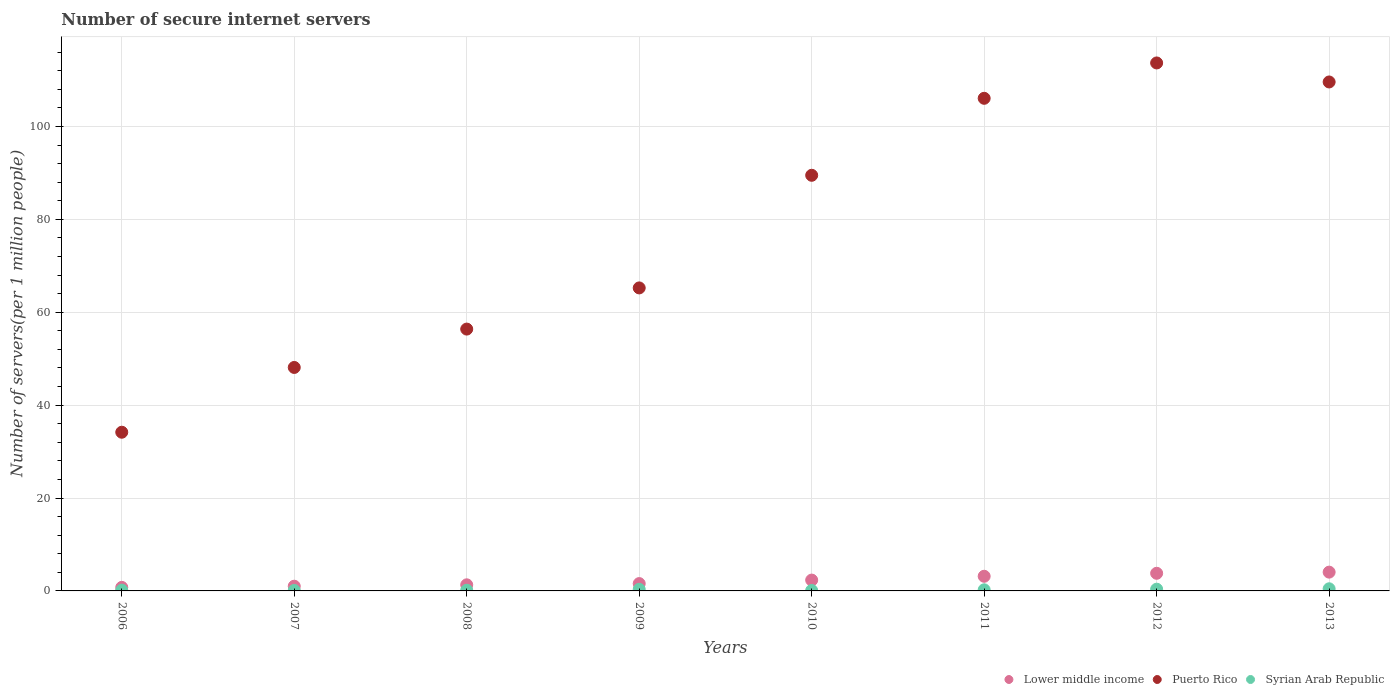Is the number of dotlines equal to the number of legend labels?
Give a very brief answer. Yes. What is the number of secure internet servers in Puerto Rico in 2006?
Make the answer very short. 34.16. Across all years, what is the maximum number of secure internet servers in Lower middle income?
Your response must be concise. 4.04. Across all years, what is the minimum number of secure internet servers in Puerto Rico?
Provide a succinct answer. 34.16. In which year was the number of secure internet servers in Puerto Rico minimum?
Provide a short and direct response. 2006. What is the total number of secure internet servers in Puerto Rico in the graph?
Offer a terse response. 622.65. What is the difference between the number of secure internet servers in Syrian Arab Republic in 2006 and that in 2010?
Make the answer very short. 0.06. What is the difference between the number of secure internet servers in Lower middle income in 2009 and the number of secure internet servers in Syrian Arab Republic in 2007?
Offer a very short reply. 1.48. What is the average number of secure internet servers in Lower middle income per year?
Give a very brief answer. 2.25. In the year 2006, what is the difference between the number of secure internet servers in Puerto Rico and number of secure internet servers in Lower middle income?
Ensure brevity in your answer.  33.4. What is the ratio of the number of secure internet servers in Lower middle income in 2006 to that in 2007?
Ensure brevity in your answer.  0.75. What is the difference between the highest and the second highest number of secure internet servers in Puerto Rico?
Your answer should be compact. 4.09. What is the difference between the highest and the lowest number of secure internet servers in Syrian Arab Republic?
Your answer should be compact. 0.36. In how many years, is the number of secure internet servers in Puerto Rico greater than the average number of secure internet servers in Puerto Rico taken over all years?
Offer a very short reply. 4. Is the sum of the number of secure internet servers in Syrian Arab Republic in 2007 and 2012 greater than the maximum number of secure internet servers in Puerto Rico across all years?
Ensure brevity in your answer.  No. Does the number of secure internet servers in Lower middle income monotonically increase over the years?
Provide a short and direct response. Yes. How many dotlines are there?
Your answer should be very brief. 3. How many years are there in the graph?
Ensure brevity in your answer.  8. What is the difference between two consecutive major ticks on the Y-axis?
Make the answer very short. 20. Does the graph contain any zero values?
Your answer should be very brief. No. Where does the legend appear in the graph?
Your answer should be compact. Bottom right. How many legend labels are there?
Give a very brief answer. 3. What is the title of the graph?
Make the answer very short. Number of secure internet servers. What is the label or title of the Y-axis?
Keep it short and to the point. Number of servers(per 1 million people). What is the Number of servers(per 1 million people) in Lower middle income in 2006?
Give a very brief answer. 0.76. What is the Number of servers(per 1 million people) of Puerto Rico in 2006?
Your answer should be compact. 34.16. What is the Number of servers(per 1 million people) in Syrian Arab Republic in 2006?
Provide a short and direct response. 0.16. What is the Number of servers(per 1 million people) of Lower middle income in 2007?
Your answer should be very brief. 1.02. What is the Number of servers(per 1 million people) in Puerto Rico in 2007?
Your answer should be very brief. 48.11. What is the Number of servers(per 1 million people) in Syrian Arab Republic in 2007?
Give a very brief answer. 0.1. What is the Number of servers(per 1 million people) in Lower middle income in 2008?
Offer a terse response. 1.31. What is the Number of servers(per 1 million people) of Puerto Rico in 2008?
Your response must be concise. 56.37. What is the Number of servers(per 1 million people) in Syrian Arab Republic in 2008?
Keep it short and to the point. 0.15. What is the Number of servers(per 1 million people) in Lower middle income in 2009?
Make the answer very short. 1.58. What is the Number of servers(per 1 million people) of Puerto Rico in 2009?
Your answer should be compact. 65.23. What is the Number of servers(per 1 million people) in Syrian Arab Republic in 2009?
Your response must be concise. 0.34. What is the Number of servers(per 1 million people) of Lower middle income in 2010?
Ensure brevity in your answer.  2.33. What is the Number of servers(per 1 million people) in Puerto Rico in 2010?
Your answer should be very brief. 89.48. What is the Number of servers(per 1 million people) in Syrian Arab Republic in 2010?
Provide a short and direct response. 0.1. What is the Number of servers(per 1 million people) of Lower middle income in 2011?
Provide a short and direct response. 3.15. What is the Number of servers(per 1 million people) of Puerto Rico in 2011?
Ensure brevity in your answer.  106.05. What is the Number of servers(per 1 million people) of Syrian Arab Republic in 2011?
Keep it short and to the point. 0.24. What is the Number of servers(per 1 million people) in Lower middle income in 2012?
Give a very brief answer. 3.8. What is the Number of servers(per 1 million people) of Puerto Rico in 2012?
Ensure brevity in your answer.  113.67. What is the Number of servers(per 1 million people) of Syrian Arab Republic in 2012?
Your response must be concise. 0.37. What is the Number of servers(per 1 million people) in Lower middle income in 2013?
Your response must be concise. 4.04. What is the Number of servers(per 1 million people) of Puerto Rico in 2013?
Provide a succinct answer. 109.57. What is the Number of servers(per 1 million people) in Syrian Arab Republic in 2013?
Make the answer very short. 0.46. Across all years, what is the maximum Number of servers(per 1 million people) of Lower middle income?
Ensure brevity in your answer.  4.04. Across all years, what is the maximum Number of servers(per 1 million people) in Puerto Rico?
Offer a very short reply. 113.67. Across all years, what is the maximum Number of servers(per 1 million people) in Syrian Arab Republic?
Keep it short and to the point. 0.46. Across all years, what is the minimum Number of servers(per 1 million people) in Lower middle income?
Your answer should be very brief. 0.76. Across all years, what is the minimum Number of servers(per 1 million people) in Puerto Rico?
Make the answer very short. 34.16. Across all years, what is the minimum Number of servers(per 1 million people) of Syrian Arab Republic?
Offer a terse response. 0.1. What is the total Number of servers(per 1 million people) of Lower middle income in the graph?
Offer a terse response. 18. What is the total Number of servers(per 1 million people) in Puerto Rico in the graph?
Offer a terse response. 622.65. What is the total Number of servers(per 1 million people) of Syrian Arab Republic in the graph?
Offer a very short reply. 1.92. What is the difference between the Number of servers(per 1 million people) in Lower middle income in 2006 and that in 2007?
Keep it short and to the point. -0.25. What is the difference between the Number of servers(per 1 million people) of Puerto Rico in 2006 and that in 2007?
Offer a very short reply. -13.95. What is the difference between the Number of servers(per 1 million people) in Syrian Arab Republic in 2006 and that in 2007?
Provide a short and direct response. 0.06. What is the difference between the Number of servers(per 1 million people) in Lower middle income in 2006 and that in 2008?
Provide a short and direct response. -0.55. What is the difference between the Number of servers(per 1 million people) in Puerto Rico in 2006 and that in 2008?
Keep it short and to the point. -22.21. What is the difference between the Number of servers(per 1 million people) in Syrian Arab Republic in 2006 and that in 2008?
Make the answer very short. 0.01. What is the difference between the Number of servers(per 1 million people) of Lower middle income in 2006 and that in 2009?
Your answer should be compact. -0.82. What is the difference between the Number of servers(per 1 million people) in Puerto Rico in 2006 and that in 2009?
Offer a terse response. -31.07. What is the difference between the Number of servers(per 1 million people) of Syrian Arab Republic in 2006 and that in 2009?
Offer a very short reply. -0.18. What is the difference between the Number of servers(per 1 million people) of Lower middle income in 2006 and that in 2010?
Keep it short and to the point. -1.57. What is the difference between the Number of servers(per 1 million people) in Puerto Rico in 2006 and that in 2010?
Make the answer very short. -55.32. What is the difference between the Number of servers(per 1 million people) of Syrian Arab Republic in 2006 and that in 2010?
Provide a succinct answer. 0.06. What is the difference between the Number of servers(per 1 million people) of Lower middle income in 2006 and that in 2011?
Offer a terse response. -2.39. What is the difference between the Number of servers(per 1 million people) of Puerto Rico in 2006 and that in 2011?
Your answer should be compact. -71.89. What is the difference between the Number of servers(per 1 million people) in Syrian Arab Republic in 2006 and that in 2011?
Your response must be concise. -0.08. What is the difference between the Number of servers(per 1 million people) in Lower middle income in 2006 and that in 2012?
Your answer should be very brief. -3.04. What is the difference between the Number of servers(per 1 million people) of Puerto Rico in 2006 and that in 2012?
Your response must be concise. -79.5. What is the difference between the Number of servers(per 1 million people) of Syrian Arab Republic in 2006 and that in 2012?
Your response must be concise. -0.21. What is the difference between the Number of servers(per 1 million people) of Lower middle income in 2006 and that in 2013?
Your response must be concise. -3.28. What is the difference between the Number of servers(per 1 million people) in Puerto Rico in 2006 and that in 2013?
Ensure brevity in your answer.  -75.41. What is the difference between the Number of servers(per 1 million people) in Syrian Arab Republic in 2006 and that in 2013?
Offer a terse response. -0.3. What is the difference between the Number of servers(per 1 million people) in Lower middle income in 2007 and that in 2008?
Your answer should be compact. -0.3. What is the difference between the Number of servers(per 1 million people) of Puerto Rico in 2007 and that in 2008?
Your response must be concise. -8.26. What is the difference between the Number of servers(per 1 million people) in Syrian Arab Republic in 2007 and that in 2008?
Your response must be concise. -0.05. What is the difference between the Number of servers(per 1 million people) in Lower middle income in 2007 and that in 2009?
Offer a very short reply. -0.57. What is the difference between the Number of servers(per 1 million people) in Puerto Rico in 2007 and that in 2009?
Give a very brief answer. -17.12. What is the difference between the Number of servers(per 1 million people) in Syrian Arab Republic in 2007 and that in 2009?
Provide a short and direct response. -0.24. What is the difference between the Number of servers(per 1 million people) in Lower middle income in 2007 and that in 2010?
Make the answer very short. -1.32. What is the difference between the Number of servers(per 1 million people) in Puerto Rico in 2007 and that in 2010?
Your answer should be compact. -41.37. What is the difference between the Number of servers(per 1 million people) of Syrian Arab Republic in 2007 and that in 2010?
Give a very brief answer. 0.01. What is the difference between the Number of servers(per 1 million people) in Lower middle income in 2007 and that in 2011?
Make the answer very short. -2.14. What is the difference between the Number of servers(per 1 million people) in Puerto Rico in 2007 and that in 2011?
Your answer should be compact. -57.94. What is the difference between the Number of servers(per 1 million people) of Syrian Arab Republic in 2007 and that in 2011?
Keep it short and to the point. -0.13. What is the difference between the Number of servers(per 1 million people) in Lower middle income in 2007 and that in 2012?
Make the answer very short. -2.78. What is the difference between the Number of servers(per 1 million people) of Puerto Rico in 2007 and that in 2012?
Ensure brevity in your answer.  -65.56. What is the difference between the Number of servers(per 1 million people) in Syrian Arab Republic in 2007 and that in 2012?
Your answer should be compact. -0.27. What is the difference between the Number of servers(per 1 million people) in Lower middle income in 2007 and that in 2013?
Ensure brevity in your answer.  -3.03. What is the difference between the Number of servers(per 1 million people) in Puerto Rico in 2007 and that in 2013?
Give a very brief answer. -61.46. What is the difference between the Number of servers(per 1 million people) of Syrian Arab Republic in 2007 and that in 2013?
Keep it short and to the point. -0.36. What is the difference between the Number of servers(per 1 million people) in Lower middle income in 2008 and that in 2009?
Offer a terse response. -0.27. What is the difference between the Number of servers(per 1 million people) in Puerto Rico in 2008 and that in 2009?
Keep it short and to the point. -8.86. What is the difference between the Number of servers(per 1 million people) of Syrian Arab Republic in 2008 and that in 2009?
Keep it short and to the point. -0.19. What is the difference between the Number of servers(per 1 million people) in Lower middle income in 2008 and that in 2010?
Provide a short and direct response. -1.02. What is the difference between the Number of servers(per 1 million people) in Puerto Rico in 2008 and that in 2010?
Offer a terse response. -33.11. What is the difference between the Number of servers(per 1 million people) in Syrian Arab Republic in 2008 and that in 2010?
Provide a short and direct response. 0.05. What is the difference between the Number of servers(per 1 million people) in Lower middle income in 2008 and that in 2011?
Provide a short and direct response. -1.84. What is the difference between the Number of servers(per 1 million people) in Puerto Rico in 2008 and that in 2011?
Ensure brevity in your answer.  -49.68. What is the difference between the Number of servers(per 1 million people) in Syrian Arab Republic in 2008 and that in 2011?
Your answer should be compact. -0.09. What is the difference between the Number of servers(per 1 million people) of Lower middle income in 2008 and that in 2012?
Make the answer very short. -2.48. What is the difference between the Number of servers(per 1 million people) of Puerto Rico in 2008 and that in 2012?
Make the answer very short. -57.3. What is the difference between the Number of servers(per 1 million people) in Syrian Arab Republic in 2008 and that in 2012?
Provide a short and direct response. -0.22. What is the difference between the Number of servers(per 1 million people) of Lower middle income in 2008 and that in 2013?
Offer a very short reply. -2.73. What is the difference between the Number of servers(per 1 million people) of Puerto Rico in 2008 and that in 2013?
Provide a succinct answer. -53.2. What is the difference between the Number of servers(per 1 million people) in Syrian Arab Republic in 2008 and that in 2013?
Keep it short and to the point. -0.31. What is the difference between the Number of servers(per 1 million people) of Lower middle income in 2009 and that in 2010?
Your response must be concise. -0.75. What is the difference between the Number of servers(per 1 million people) of Puerto Rico in 2009 and that in 2010?
Make the answer very short. -24.25. What is the difference between the Number of servers(per 1 million people) of Syrian Arab Republic in 2009 and that in 2010?
Provide a short and direct response. 0.24. What is the difference between the Number of servers(per 1 million people) in Lower middle income in 2009 and that in 2011?
Your answer should be compact. -1.57. What is the difference between the Number of servers(per 1 million people) of Puerto Rico in 2009 and that in 2011?
Offer a terse response. -40.82. What is the difference between the Number of servers(per 1 million people) in Syrian Arab Republic in 2009 and that in 2011?
Give a very brief answer. 0.1. What is the difference between the Number of servers(per 1 million people) in Lower middle income in 2009 and that in 2012?
Offer a very short reply. -2.22. What is the difference between the Number of servers(per 1 million people) of Puerto Rico in 2009 and that in 2012?
Ensure brevity in your answer.  -48.43. What is the difference between the Number of servers(per 1 million people) of Syrian Arab Republic in 2009 and that in 2012?
Give a very brief answer. -0.03. What is the difference between the Number of servers(per 1 million people) of Lower middle income in 2009 and that in 2013?
Give a very brief answer. -2.46. What is the difference between the Number of servers(per 1 million people) of Puerto Rico in 2009 and that in 2013?
Offer a terse response. -44.34. What is the difference between the Number of servers(per 1 million people) in Syrian Arab Republic in 2009 and that in 2013?
Give a very brief answer. -0.12. What is the difference between the Number of servers(per 1 million people) in Lower middle income in 2010 and that in 2011?
Offer a terse response. -0.82. What is the difference between the Number of servers(per 1 million people) of Puerto Rico in 2010 and that in 2011?
Ensure brevity in your answer.  -16.58. What is the difference between the Number of servers(per 1 million people) of Syrian Arab Republic in 2010 and that in 2011?
Provide a succinct answer. -0.14. What is the difference between the Number of servers(per 1 million people) of Lower middle income in 2010 and that in 2012?
Your response must be concise. -1.46. What is the difference between the Number of servers(per 1 million people) in Puerto Rico in 2010 and that in 2012?
Keep it short and to the point. -24.19. What is the difference between the Number of servers(per 1 million people) of Syrian Arab Republic in 2010 and that in 2012?
Your answer should be very brief. -0.28. What is the difference between the Number of servers(per 1 million people) of Lower middle income in 2010 and that in 2013?
Provide a succinct answer. -1.71. What is the difference between the Number of servers(per 1 million people) in Puerto Rico in 2010 and that in 2013?
Ensure brevity in your answer.  -20.09. What is the difference between the Number of servers(per 1 million people) of Syrian Arab Republic in 2010 and that in 2013?
Make the answer very short. -0.36. What is the difference between the Number of servers(per 1 million people) in Lower middle income in 2011 and that in 2012?
Give a very brief answer. -0.64. What is the difference between the Number of servers(per 1 million people) in Puerto Rico in 2011 and that in 2012?
Provide a succinct answer. -7.61. What is the difference between the Number of servers(per 1 million people) in Syrian Arab Republic in 2011 and that in 2012?
Provide a succinct answer. -0.14. What is the difference between the Number of servers(per 1 million people) of Lower middle income in 2011 and that in 2013?
Provide a short and direct response. -0.89. What is the difference between the Number of servers(per 1 million people) of Puerto Rico in 2011 and that in 2013?
Ensure brevity in your answer.  -3.52. What is the difference between the Number of servers(per 1 million people) of Syrian Arab Republic in 2011 and that in 2013?
Provide a short and direct response. -0.22. What is the difference between the Number of servers(per 1 million people) of Lower middle income in 2012 and that in 2013?
Provide a short and direct response. -0.25. What is the difference between the Number of servers(per 1 million people) in Puerto Rico in 2012 and that in 2013?
Ensure brevity in your answer.  4.09. What is the difference between the Number of servers(per 1 million people) in Syrian Arab Republic in 2012 and that in 2013?
Provide a short and direct response. -0.09. What is the difference between the Number of servers(per 1 million people) in Lower middle income in 2006 and the Number of servers(per 1 million people) in Puerto Rico in 2007?
Ensure brevity in your answer.  -47.35. What is the difference between the Number of servers(per 1 million people) in Lower middle income in 2006 and the Number of servers(per 1 million people) in Syrian Arab Republic in 2007?
Provide a short and direct response. 0.66. What is the difference between the Number of servers(per 1 million people) of Puerto Rico in 2006 and the Number of servers(per 1 million people) of Syrian Arab Republic in 2007?
Provide a short and direct response. 34.06. What is the difference between the Number of servers(per 1 million people) of Lower middle income in 2006 and the Number of servers(per 1 million people) of Puerto Rico in 2008?
Make the answer very short. -55.61. What is the difference between the Number of servers(per 1 million people) in Lower middle income in 2006 and the Number of servers(per 1 million people) in Syrian Arab Republic in 2008?
Offer a very short reply. 0.61. What is the difference between the Number of servers(per 1 million people) of Puerto Rico in 2006 and the Number of servers(per 1 million people) of Syrian Arab Republic in 2008?
Your response must be concise. 34.01. What is the difference between the Number of servers(per 1 million people) of Lower middle income in 2006 and the Number of servers(per 1 million people) of Puerto Rico in 2009?
Your response must be concise. -64.47. What is the difference between the Number of servers(per 1 million people) in Lower middle income in 2006 and the Number of servers(per 1 million people) in Syrian Arab Republic in 2009?
Your answer should be very brief. 0.42. What is the difference between the Number of servers(per 1 million people) of Puerto Rico in 2006 and the Number of servers(per 1 million people) of Syrian Arab Republic in 2009?
Provide a short and direct response. 33.82. What is the difference between the Number of servers(per 1 million people) of Lower middle income in 2006 and the Number of servers(per 1 million people) of Puerto Rico in 2010?
Ensure brevity in your answer.  -88.72. What is the difference between the Number of servers(per 1 million people) of Lower middle income in 2006 and the Number of servers(per 1 million people) of Syrian Arab Republic in 2010?
Provide a succinct answer. 0.67. What is the difference between the Number of servers(per 1 million people) in Puerto Rico in 2006 and the Number of servers(per 1 million people) in Syrian Arab Republic in 2010?
Your response must be concise. 34.07. What is the difference between the Number of servers(per 1 million people) in Lower middle income in 2006 and the Number of servers(per 1 million people) in Puerto Rico in 2011?
Your answer should be very brief. -105.29. What is the difference between the Number of servers(per 1 million people) in Lower middle income in 2006 and the Number of servers(per 1 million people) in Syrian Arab Republic in 2011?
Your answer should be very brief. 0.52. What is the difference between the Number of servers(per 1 million people) in Puerto Rico in 2006 and the Number of servers(per 1 million people) in Syrian Arab Republic in 2011?
Your response must be concise. 33.93. What is the difference between the Number of servers(per 1 million people) in Lower middle income in 2006 and the Number of servers(per 1 million people) in Puerto Rico in 2012?
Offer a very short reply. -112.9. What is the difference between the Number of servers(per 1 million people) of Lower middle income in 2006 and the Number of servers(per 1 million people) of Syrian Arab Republic in 2012?
Your answer should be compact. 0.39. What is the difference between the Number of servers(per 1 million people) of Puerto Rico in 2006 and the Number of servers(per 1 million people) of Syrian Arab Republic in 2012?
Make the answer very short. 33.79. What is the difference between the Number of servers(per 1 million people) in Lower middle income in 2006 and the Number of servers(per 1 million people) in Puerto Rico in 2013?
Provide a succinct answer. -108.81. What is the difference between the Number of servers(per 1 million people) of Lower middle income in 2006 and the Number of servers(per 1 million people) of Syrian Arab Republic in 2013?
Provide a short and direct response. 0.3. What is the difference between the Number of servers(per 1 million people) in Puerto Rico in 2006 and the Number of servers(per 1 million people) in Syrian Arab Republic in 2013?
Ensure brevity in your answer.  33.7. What is the difference between the Number of servers(per 1 million people) of Lower middle income in 2007 and the Number of servers(per 1 million people) of Puerto Rico in 2008?
Your answer should be very brief. -55.35. What is the difference between the Number of servers(per 1 million people) in Lower middle income in 2007 and the Number of servers(per 1 million people) in Syrian Arab Republic in 2008?
Your answer should be compact. 0.87. What is the difference between the Number of servers(per 1 million people) in Puerto Rico in 2007 and the Number of servers(per 1 million people) in Syrian Arab Republic in 2008?
Your answer should be compact. 47.96. What is the difference between the Number of servers(per 1 million people) in Lower middle income in 2007 and the Number of servers(per 1 million people) in Puerto Rico in 2009?
Your answer should be compact. -64.22. What is the difference between the Number of servers(per 1 million people) of Lower middle income in 2007 and the Number of servers(per 1 million people) of Syrian Arab Republic in 2009?
Offer a terse response. 0.67. What is the difference between the Number of servers(per 1 million people) in Puerto Rico in 2007 and the Number of servers(per 1 million people) in Syrian Arab Republic in 2009?
Your answer should be very brief. 47.77. What is the difference between the Number of servers(per 1 million people) of Lower middle income in 2007 and the Number of servers(per 1 million people) of Puerto Rico in 2010?
Provide a short and direct response. -88.46. What is the difference between the Number of servers(per 1 million people) in Lower middle income in 2007 and the Number of servers(per 1 million people) in Syrian Arab Republic in 2010?
Ensure brevity in your answer.  0.92. What is the difference between the Number of servers(per 1 million people) in Puerto Rico in 2007 and the Number of servers(per 1 million people) in Syrian Arab Republic in 2010?
Your answer should be compact. 48.01. What is the difference between the Number of servers(per 1 million people) in Lower middle income in 2007 and the Number of servers(per 1 million people) in Puerto Rico in 2011?
Provide a short and direct response. -105.04. What is the difference between the Number of servers(per 1 million people) in Lower middle income in 2007 and the Number of servers(per 1 million people) in Syrian Arab Republic in 2011?
Provide a succinct answer. 0.78. What is the difference between the Number of servers(per 1 million people) of Puerto Rico in 2007 and the Number of servers(per 1 million people) of Syrian Arab Republic in 2011?
Offer a very short reply. 47.87. What is the difference between the Number of servers(per 1 million people) of Lower middle income in 2007 and the Number of servers(per 1 million people) of Puerto Rico in 2012?
Provide a short and direct response. -112.65. What is the difference between the Number of servers(per 1 million people) in Lower middle income in 2007 and the Number of servers(per 1 million people) in Syrian Arab Republic in 2012?
Your answer should be very brief. 0.64. What is the difference between the Number of servers(per 1 million people) of Puerto Rico in 2007 and the Number of servers(per 1 million people) of Syrian Arab Republic in 2012?
Your answer should be very brief. 47.74. What is the difference between the Number of servers(per 1 million people) in Lower middle income in 2007 and the Number of servers(per 1 million people) in Puerto Rico in 2013?
Your answer should be compact. -108.56. What is the difference between the Number of servers(per 1 million people) in Lower middle income in 2007 and the Number of servers(per 1 million people) in Syrian Arab Republic in 2013?
Provide a short and direct response. 0.56. What is the difference between the Number of servers(per 1 million people) of Puerto Rico in 2007 and the Number of servers(per 1 million people) of Syrian Arab Republic in 2013?
Provide a succinct answer. 47.65. What is the difference between the Number of servers(per 1 million people) of Lower middle income in 2008 and the Number of servers(per 1 million people) of Puerto Rico in 2009?
Keep it short and to the point. -63.92. What is the difference between the Number of servers(per 1 million people) in Lower middle income in 2008 and the Number of servers(per 1 million people) in Syrian Arab Republic in 2009?
Ensure brevity in your answer.  0.97. What is the difference between the Number of servers(per 1 million people) of Puerto Rico in 2008 and the Number of servers(per 1 million people) of Syrian Arab Republic in 2009?
Provide a short and direct response. 56.03. What is the difference between the Number of servers(per 1 million people) of Lower middle income in 2008 and the Number of servers(per 1 million people) of Puerto Rico in 2010?
Ensure brevity in your answer.  -88.17. What is the difference between the Number of servers(per 1 million people) of Lower middle income in 2008 and the Number of servers(per 1 million people) of Syrian Arab Republic in 2010?
Your response must be concise. 1.22. What is the difference between the Number of servers(per 1 million people) in Puerto Rico in 2008 and the Number of servers(per 1 million people) in Syrian Arab Republic in 2010?
Keep it short and to the point. 56.27. What is the difference between the Number of servers(per 1 million people) of Lower middle income in 2008 and the Number of servers(per 1 million people) of Puerto Rico in 2011?
Offer a terse response. -104.74. What is the difference between the Number of servers(per 1 million people) of Lower middle income in 2008 and the Number of servers(per 1 million people) of Syrian Arab Republic in 2011?
Offer a terse response. 1.08. What is the difference between the Number of servers(per 1 million people) in Puerto Rico in 2008 and the Number of servers(per 1 million people) in Syrian Arab Republic in 2011?
Your answer should be very brief. 56.13. What is the difference between the Number of servers(per 1 million people) in Lower middle income in 2008 and the Number of servers(per 1 million people) in Puerto Rico in 2012?
Provide a succinct answer. -112.35. What is the difference between the Number of servers(per 1 million people) in Lower middle income in 2008 and the Number of servers(per 1 million people) in Syrian Arab Republic in 2012?
Ensure brevity in your answer.  0.94. What is the difference between the Number of servers(per 1 million people) of Puerto Rico in 2008 and the Number of servers(per 1 million people) of Syrian Arab Republic in 2012?
Offer a very short reply. 56. What is the difference between the Number of servers(per 1 million people) of Lower middle income in 2008 and the Number of servers(per 1 million people) of Puerto Rico in 2013?
Keep it short and to the point. -108.26. What is the difference between the Number of servers(per 1 million people) of Lower middle income in 2008 and the Number of servers(per 1 million people) of Syrian Arab Republic in 2013?
Your answer should be very brief. 0.85. What is the difference between the Number of servers(per 1 million people) in Puerto Rico in 2008 and the Number of servers(per 1 million people) in Syrian Arab Republic in 2013?
Your response must be concise. 55.91. What is the difference between the Number of servers(per 1 million people) of Lower middle income in 2009 and the Number of servers(per 1 million people) of Puerto Rico in 2010?
Offer a terse response. -87.9. What is the difference between the Number of servers(per 1 million people) in Lower middle income in 2009 and the Number of servers(per 1 million people) in Syrian Arab Republic in 2010?
Keep it short and to the point. 1.48. What is the difference between the Number of servers(per 1 million people) of Puerto Rico in 2009 and the Number of servers(per 1 million people) of Syrian Arab Republic in 2010?
Give a very brief answer. 65.14. What is the difference between the Number of servers(per 1 million people) in Lower middle income in 2009 and the Number of servers(per 1 million people) in Puerto Rico in 2011?
Provide a succinct answer. -104.47. What is the difference between the Number of servers(per 1 million people) of Lower middle income in 2009 and the Number of servers(per 1 million people) of Syrian Arab Republic in 2011?
Provide a short and direct response. 1.34. What is the difference between the Number of servers(per 1 million people) in Puerto Rico in 2009 and the Number of servers(per 1 million people) in Syrian Arab Republic in 2011?
Provide a succinct answer. 65. What is the difference between the Number of servers(per 1 million people) in Lower middle income in 2009 and the Number of servers(per 1 million people) in Puerto Rico in 2012?
Ensure brevity in your answer.  -112.08. What is the difference between the Number of servers(per 1 million people) of Lower middle income in 2009 and the Number of servers(per 1 million people) of Syrian Arab Republic in 2012?
Your answer should be very brief. 1.21. What is the difference between the Number of servers(per 1 million people) of Puerto Rico in 2009 and the Number of servers(per 1 million people) of Syrian Arab Republic in 2012?
Your answer should be very brief. 64.86. What is the difference between the Number of servers(per 1 million people) of Lower middle income in 2009 and the Number of servers(per 1 million people) of Puerto Rico in 2013?
Offer a very short reply. -107.99. What is the difference between the Number of servers(per 1 million people) in Lower middle income in 2009 and the Number of servers(per 1 million people) in Syrian Arab Republic in 2013?
Give a very brief answer. 1.12. What is the difference between the Number of servers(per 1 million people) of Puerto Rico in 2009 and the Number of servers(per 1 million people) of Syrian Arab Republic in 2013?
Keep it short and to the point. 64.77. What is the difference between the Number of servers(per 1 million people) in Lower middle income in 2010 and the Number of servers(per 1 million people) in Puerto Rico in 2011?
Keep it short and to the point. -103.72. What is the difference between the Number of servers(per 1 million people) of Lower middle income in 2010 and the Number of servers(per 1 million people) of Syrian Arab Republic in 2011?
Offer a terse response. 2.1. What is the difference between the Number of servers(per 1 million people) of Puerto Rico in 2010 and the Number of servers(per 1 million people) of Syrian Arab Republic in 2011?
Ensure brevity in your answer.  89.24. What is the difference between the Number of servers(per 1 million people) of Lower middle income in 2010 and the Number of servers(per 1 million people) of Puerto Rico in 2012?
Give a very brief answer. -111.33. What is the difference between the Number of servers(per 1 million people) of Lower middle income in 2010 and the Number of servers(per 1 million people) of Syrian Arab Republic in 2012?
Your answer should be very brief. 1.96. What is the difference between the Number of servers(per 1 million people) of Puerto Rico in 2010 and the Number of servers(per 1 million people) of Syrian Arab Republic in 2012?
Offer a terse response. 89.11. What is the difference between the Number of servers(per 1 million people) in Lower middle income in 2010 and the Number of servers(per 1 million people) in Puerto Rico in 2013?
Make the answer very short. -107.24. What is the difference between the Number of servers(per 1 million people) in Lower middle income in 2010 and the Number of servers(per 1 million people) in Syrian Arab Republic in 2013?
Offer a very short reply. 1.87. What is the difference between the Number of servers(per 1 million people) of Puerto Rico in 2010 and the Number of servers(per 1 million people) of Syrian Arab Republic in 2013?
Offer a very short reply. 89.02. What is the difference between the Number of servers(per 1 million people) of Lower middle income in 2011 and the Number of servers(per 1 million people) of Puerto Rico in 2012?
Provide a succinct answer. -110.51. What is the difference between the Number of servers(per 1 million people) in Lower middle income in 2011 and the Number of servers(per 1 million people) in Syrian Arab Republic in 2012?
Provide a succinct answer. 2.78. What is the difference between the Number of servers(per 1 million people) of Puerto Rico in 2011 and the Number of servers(per 1 million people) of Syrian Arab Republic in 2012?
Offer a very short reply. 105.68. What is the difference between the Number of servers(per 1 million people) in Lower middle income in 2011 and the Number of servers(per 1 million people) in Puerto Rico in 2013?
Give a very brief answer. -106.42. What is the difference between the Number of servers(per 1 million people) in Lower middle income in 2011 and the Number of servers(per 1 million people) in Syrian Arab Republic in 2013?
Keep it short and to the point. 2.69. What is the difference between the Number of servers(per 1 million people) in Puerto Rico in 2011 and the Number of servers(per 1 million people) in Syrian Arab Republic in 2013?
Your answer should be very brief. 105.6. What is the difference between the Number of servers(per 1 million people) of Lower middle income in 2012 and the Number of servers(per 1 million people) of Puerto Rico in 2013?
Your answer should be very brief. -105.77. What is the difference between the Number of servers(per 1 million people) in Lower middle income in 2012 and the Number of servers(per 1 million people) in Syrian Arab Republic in 2013?
Give a very brief answer. 3.34. What is the difference between the Number of servers(per 1 million people) in Puerto Rico in 2012 and the Number of servers(per 1 million people) in Syrian Arab Republic in 2013?
Offer a terse response. 113.21. What is the average Number of servers(per 1 million people) in Lower middle income per year?
Make the answer very short. 2.25. What is the average Number of servers(per 1 million people) of Puerto Rico per year?
Provide a succinct answer. 77.83. What is the average Number of servers(per 1 million people) in Syrian Arab Republic per year?
Give a very brief answer. 0.24. In the year 2006, what is the difference between the Number of servers(per 1 million people) of Lower middle income and Number of servers(per 1 million people) of Puerto Rico?
Your response must be concise. -33.4. In the year 2006, what is the difference between the Number of servers(per 1 million people) of Lower middle income and Number of servers(per 1 million people) of Syrian Arab Republic?
Ensure brevity in your answer.  0.6. In the year 2006, what is the difference between the Number of servers(per 1 million people) in Puerto Rico and Number of servers(per 1 million people) in Syrian Arab Republic?
Provide a short and direct response. 34. In the year 2007, what is the difference between the Number of servers(per 1 million people) in Lower middle income and Number of servers(per 1 million people) in Puerto Rico?
Provide a short and direct response. -47.09. In the year 2007, what is the difference between the Number of servers(per 1 million people) of Lower middle income and Number of servers(per 1 million people) of Syrian Arab Republic?
Your answer should be very brief. 0.91. In the year 2007, what is the difference between the Number of servers(per 1 million people) of Puerto Rico and Number of servers(per 1 million people) of Syrian Arab Republic?
Give a very brief answer. 48.01. In the year 2008, what is the difference between the Number of servers(per 1 million people) of Lower middle income and Number of servers(per 1 million people) of Puerto Rico?
Provide a succinct answer. -55.06. In the year 2008, what is the difference between the Number of servers(per 1 million people) in Lower middle income and Number of servers(per 1 million people) in Syrian Arab Republic?
Your response must be concise. 1.16. In the year 2008, what is the difference between the Number of servers(per 1 million people) in Puerto Rico and Number of servers(per 1 million people) in Syrian Arab Republic?
Keep it short and to the point. 56.22. In the year 2009, what is the difference between the Number of servers(per 1 million people) in Lower middle income and Number of servers(per 1 million people) in Puerto Rico?
Give a very brief answer. -63.65. In the year 2009, what is the difference between the Number of servers(per 1 million people) of Lower middle income and Number of servers(per 1 million people) of Syrian Arab Republic?
Ensure brevity in your answer.  1.24. In the year 2009, what is the difference between the Number of servers(per 1 million people) in Puerto Rico and Number of servers(per 1 million people) in Syrian Arab Republic?
Offer a very short reply. 64.89. In the year 2010, what is the difference between the Number of servers(per 1 million people) of Lower middle income and Number of servers(per 1 million people) of Puerto Rico?
Provide a short and direct response. -87.15. In the year 2010, what is the difference between the Number of servers(per 1 million people) in Lower middle income and Number of servers(per 1 million people) in Syrian Arab Republic?
Keep it short and to the point. 2.24. In the year 2010, what is the difference between the Number of servers(per 1 million people) in Puerto Rico and Number of servers(per 1 million people) in Syrian Arab Republic?
Offer a very short reply. 89.38. In the year 2011, what is the difference between the Number of servers(per 1 million people) in Lower middle income and Number of servers(per 1 million people) in Puerto Rico?
Keep it short and to the point. -102.9. In the year 2011, what is the difference between the Number of servers(per 1 million people) of Lower middle income and Number of servers(per 1 million people) of Syrian Arab Republic?
Offer a terse response. 2.92. In the year 2011, what is the difference between the Number of servers(per 1 million people) of Puerto Rico and Number of servers(per 1 million people) of Syrian Arab Republic?
Your response must be concise. 105.82. In the year 2012, what is the difference between the Number of servers(per 1 million people) in Lower middle income and Number of servers(per 1 million people) in Puerto Rico?
Provide a short and direct response. -109.87. In the year 2012, what is the difference between the Number of servers(per 1 million people) of Lower middle income and Number of servers(per 1 million people) of Syrian Arab Republic?
Ensure brevity in your answer.  3.42. In the year 2012, what is the difference between the Number of servers(per 1 million people) in Puerto Rico and Number of servers(per 1 million people) in Syrian Arab Republic?
Provide a succinct answer. 113.29. In the year 2013, what is the difference between the Number of servers(per 1 million people) in Lower middle income and Number of servers(per 1 million people) in Puerto Rico?
Ensure brevity in your answer.  -105.53. In the year 2013, what is the difference between the Number of servers(per 1 million people) of Lower middle income and Number of servers(per 1 million people) of Syrian Arab Republic?
Make the answer very short. 3.58. In the year 2013, what is the difference between the Number of servers(per 1 million people) in Puerto Rico and Number of servers(per 1 million people) in Syrian Arab Republic?
Keep it short and to the point. 109.11. What is the ratio of the Number of servers(per 1 million people) of Lower middle income in 2006 to that in 2007?
Offer a very short reply. 0.75. What is the ratio of the Number of servers(per 1 million people) of Puerto Rico in 2006 to that in 2007?
Make the answer very short. 0.71. What is the ratio of the Number of servers(per 1 million people) of Syrian Arab Republic in 2006 to that in 2007?
Your answer should be very brief. 1.56. What is the ratio of the Number of servers(per 1 million people) of Lower middle income in 2006 to that in 2008?
Provide a succinct answer. 0.58. What is the ratio of the Number of servers(per 1 million people) in Puerto Rico in 2006 to that in 2008?
Your answer should be compact. 0.61. What is the ratio of the Number of servers(per 1 million people) in Syrian Arab Republic in 2006 to that in 2008?
Keep it short and to the point. 1.07. What is the ratio of the Number of servers(per 1 million people) of Lower middle income in 2006 to that in 2009?
Make the answer very short. 0.48. What is the ratio of the Number of servers(per 1 million people) of Puerto Rico in 2006 to that in 2009?
Your answer should be compact. 0.52. What is the ratio of the Number of servers(per 1 million people) of Syrian Arab Republic in 2006 to that in 2009?
Your response must be concise. 0.47. What is the ratio of the Number of servers(per 1 million people) of Lower middle income in 2006 to that in 2010?
Give a very brief answer. 0.33. What is the ratio of the Number of servers(per 1 million people) in Puerto Rico in 2006 to that in 2010?
Ensure brevity in your answer.  0.38. What is the ratio of the Number of servers(per 1 million people) in Syrian Arab Republic in 2006 to that in 2010?
Offer a terse response. 1.66. What is the ratio of the Number of servers(per 1 million people) of Lower middle income in 2006 to that in 2011?
Give a very brief answer. 0.24. What is the ratio of the Number of servers(per 1 million people) of Puerto Rico in 2006 to that in 2011?
Your answer should be very brief. 0.32. What is the ratio of the Number of servers(per 1 million people) in Syrian Arab Republic in 2006 to that in 2011?
Your answer should be very brief. 0.68. What is the ratio of the Number of servers(per 1 million people) of Lower middle income in 2006 to that in 2012?
Make the answer very short. 0.2. What is the ratio of the Number of servers(per 1 million people) of Puerto Rico in 2006 to that in 2012?
Provide a succinct answer. 0.3. What is the ratio of the Number of servers(per 1 million people) in Syrian Arab Republic in 2006 to that in 2012?
Your answer should be very brief. 0.43. What is the ratio of the Number of servers(per 1 million people) of Lower middle income in 2006 to that in 2013?
Offer a terse response. 0.19. What is the ratio of the Number of servers(per 1 million people) of Puerto Rico in 2006 to that in 2013?
Offer a very short reply. 0.31. What is the ratio of the Number of servers(per 1 million people) of Syrian Arab Republic in 2006 to that in 2013?
Offer a very short reply. 0.35. What is the ratio of the Number of servers(per 1 million people) in Lower middle income in 2007 to that in 2008?
Your answer should be very brief. 0.77. What is the ratio of the Number of servers(per 1 million people) of Puerto Rico in 2007 to that in 2008?
Ensure brevity in your answer.  0.85. What is the ratio of the Number of servers(per 1 million people) in Syrian Arab Republic in 2007 to that in 2008?
Give a very brief answer. 0.69. What is the ratio of the Number of servers(per 1 million people) of Lower middle income in 2007 to that in 2009?
Give a very brief answer. 0.64. What is the ratio of the Number of servers(per 1 million people) in Puerto Rico in 2007 to that in 2009?
Your answer should be very brief. 0.74. What is the ratio of the Number of servers(per 1 million people) in Syrian Arab Republic in 2007 to that in 2009?
Ensure brevity in your answer.  0.3. What is the ratio of the Number of servers(per 1 million people) in Lower middle income in 2007 to that in 2010?
Give a very brief answer. 0.43. What is the ratio of the Number of servers(per 1 million people) in Puerto Rico in 2007 to that in 2010?
Ensure brevity in your answer.  0.54. What is the ratio of the Number of servers(per 1 million people) of Syrian Arab Republic in 2007 to that in 2010?
Provide a short and direct response. 1.07. What is the ratio of the Number of servers(per 1 million people) of Lower middle income in 2007 to that in 2011?
Provide a short and direct response. 0.32. What is the ratio of the Number of servers(per 1 million people) of Puerto Rico in 2007 to that in 2011?
Ensure brevity in your answer.  0.45. What is the ratio of the Number of servers(per 1 million people) in Syrian Arab Republic in 2007 to that in 2011?
Offer a very short reply. 0.43. What is the ratio of the Number of servers(per 1 million people) of Lower middle income in 2007 to that in 2012?
Your answer should be compact. 0.27. What is the ratio of the Number of servers(per 1 million people) of Puerto Rico in 2007 to that in 2012?
Make the answer very short. 0.42. What is the ratio of the Number of servers(per 1 million people) in Syrian Arab Republic in 2007 to that in 2012?
Provide a short and direct response. 0.28. What is the ratio of the Number of servers(per 1 million people) of Lower middle income in 2007 to that in 2013?
Keep it short and to the point. 0.25. What is the ratio of the Number of servers(per 1 million people) in Puerto Rico in 2007 to that in 2013?
Ensure brevity in your answer.  0.44. What is the ratio of the Number of servers(per 1 million people) of Syrian Arab Republic in 2007 to that in 2013?
Make the answer very short. 0.22. What is the ratio of the Number of servers(per 1 million people) of Lower middle income in 2008 to that in 2009?
Make the answer very short. 0.83. What is the ratio of the Number of servers(per 1 million people) of Puerto Rico in 2008 to that in 2009?
Give a very brief answer. 0.86. What is the ratio of the Number of servers(per 1 million people) of Syrian Arab Republic in 2008 to that in 2009?
Ensure brevity in your answer.  0.44. What is the ratio of the Number of servers(per 1 million people) in Lower middle income in 2008 to that in 2010?
Your answer should be compact. 0.56. What is the ratio of the Number of servers(per 1 million people) in Puerto Rico in 2008 to that in 2010?
Provide a succinct answer. 0.63. What is the ratio of the Number of servers(per 1 million people) of Syrian Arab Republic in 2008 to that in 2010?
Your answer should be compact. 1.55. What is the ratio of the Number of servers(per 1 million people) in Lower middle income in 2008 to that in 2011?
Provide a succinct answer. 0.42. What is the ratio of the Number of servers(per 1 million people) in Puerto Rico in 2008 to that in 2011?
Give a very brief answer. 0.53. What is the ratio of the Number of servers(per 1 million people) of Syrian Arab Republic in 2008 to that in 2011?
Your answer should be very brief. 0.63. What is the ratio of the Number of servers(per 1 million people) of Lower middle income in 2008 to that in 2012?
Give a very brief answer. 0.35. What is the ratio of the Number of servers(per 1 million people) in Puerto Rico in 2008 to that in 2012?
Provide a succinct answer. 0.5. What is the ratio of the Number of servers(per 1 million people) in Syrian Arab Republic in 2008 to that in 2012?
Give a very brief answer. 0.4. What is the ratio of the Number of servers(per 1 million people) in Lower middle income in 2008 to that in 2013?
Give a very brief answer. 0.32. What is the ratio of the Number of servers(per 1 million people) of Puerto Rico in 2008 to that in 2013?
Offer a terse response. 0.51. What is the ratio of the Number of servers(per 1 million people) in Syrian Arab Republic in 2008 to that in 2013?
Your answer should be very brief. 0.33. What is the ratio of the Number of servers(per 1 million people) in Lower middle income in 2009 to that in 2010?
Keep it short and to the point. 0.68. What is the ratio of the Number of servers(per 1 million people) of Puerto Rico in 2009 to that in 2010?
Make the answer very short. 0.73. What is the ratio of the Number of servers(per 1 million people) in Syrian Arab Republic in 2009 to that in 2010?
Your answer should be compact. 3.53. What is the ratio of the Number of servers(per 1 million people) of Lower middle income in 2009 to that in 2011?
Provide a succinct answer. 0.5. What is the ratio of the Number of servers(per 1 million people) of Puerto Rico in 2009 to that in 2011?
Provide a short and direct response. 0.62. What is the ratio of the Number of servers(per 1 million people) of Syrian Arab Republic in 2009 to that in 2011?
Provide a short and direct response. 1.43. What is the ratio of the Number of servers(per 1 million people) of Lower middle income in 2009 to that in 2012?
Keep it short and to the point. 0.42. What is the ratio of the Number of servers(per 1 million people) in Puerto Rico in 2009 to that in 2012?
Your answer should be compact. 0.57. What is the ratio of the Number of servers(per 1 million people) in Syrian Arab Republic in 2009 to that in 2012?
Make the answer very short. 0.91. What is the ratio of the Number of servers(per 1 million people) of Lower middle income in 2009 to that in 2013?
Offer a very short reply. 0.39. What is the ratio of the Number of servers(per 1 million people) in Puerto Rico in 2009 to that in 2013?
Keep it short and to the point. 0.6. What is the ratio of the Number of servers(per 1 million people) in Syrian Arab Republic in 2009 to that in 2013?
Your answer should be compact. 0.74. What is the ratio of the Number of servers(per 1 million people) in Lower middle income in 2010 to that in 2011?
Your answer should be compact. 0.74. What is the ratio of the Number of servers(per 1 million people) in Puerto Rico in 2010 to that in 2011?
Offer a very short reply. 0.84. What is the ratio of the Number of servers(per 1 million people) in Syrian Arab Republic in 2010 to that in 2011?
Offer a very short reply. 0.41. What is the ratio of the Number of servers(per 1 million people) of Lower middle income in 2010 to that in 2012?
Keep it short and to the point. 0.61. What is the ratio of the Number of servers(per 1 million people) in Puerto Rico in 2010 to that in 2012?
Make the answer very short. 0.79. What is the ratio of the Number of servers(per 1 million people) of Syrian Arab Republic in 2010 to that in 2012?
Offer a terse response. 0.26. What is the ratio of the Number of servers(per 1 million people) in Lower middle income in 2010 to that in 2013?
Ensure brevity in your answer.  0.58. What is the ratio of the Number of servers(per 1 million people) of Puerto Rico in 2010 to that in 2013?
Provide a succinct answer. 0.82. What is the ratio of the Number of servers(per 1 million people) in Syrian Arab Republic in 2010 to that in 2013?
Give a very brief answer. 0.21. What is the ratio of the Number of servers(per 1 million people) in Lower middle income in 2011 to that in 2012?
Your answer should be very brief. 0.83. What is the ratio of the Number of servers(per 1 million people) in Puerto Rico in 2011 to that in 2012?
Provide a short and direct response. 0.93. What is the ratio of the Number of servers(per 1 million people) in Syrian Arab Republic in 2011 to that in 2012?
Provide a short and direct response. 0.64. What is the ratio of the Number of servers(per 1 million people) of Lower middle income in 2011 to that in 2013?
Your response must be concise. 0.78. What is the ratio of the Number of servers(per 1 million people) in Puerto Rico in 2011 to that in 2013?
Make the answer very short. 0.97. What is the ratio of the Number of servers(per 1 million people) of Syrian Arab Republic in 2011 to that in 2013?
Ensure brevity in your answer.  0.52. What is the ratio of the Number of servers(per 1 million people) of Lower middle income in 2012 to that in 2013?
Your answer should be compact. 0.94. What is the ratio of the Number of servers(per 1 million people) in Puerto Rico in 2012 to that in 2013?
Give a very brief answer. 1.04. What is the ratio of the Number of servers(per 1 million people) in Syrian Arab Republic in 2012 to that in 2013?
Ensure brevity in your answer.  0.81. What is the difference between the highest and the second highest Number of servers(per 1 million people) of Lower middle income?
Make the answer very short. 0.25. What is the difference between the highest and the second highest Number of servers(per 1 million people) of Puerto Rico?
Your answer should be very brief. 4.09. What is the difference between the highest and the second highest Number of servers(per 1 million people) in Syrian Arab Republic?
Your response must be concise. 0.09. What is the difference between the highest and the lowest Number of servers(per 1 million people) in Lower middle income?
Offer a terse response. 3.28. What is the difference between the highest and the lowest Number of servers(per 1 million people) in Puerto Rico?
Your answer should be compact. 79.5. What is the difference between the highest and the lowest Number of servers(per 1 million people) of Syrian Arab Republic?
Give a very brief answer. 0.36. 